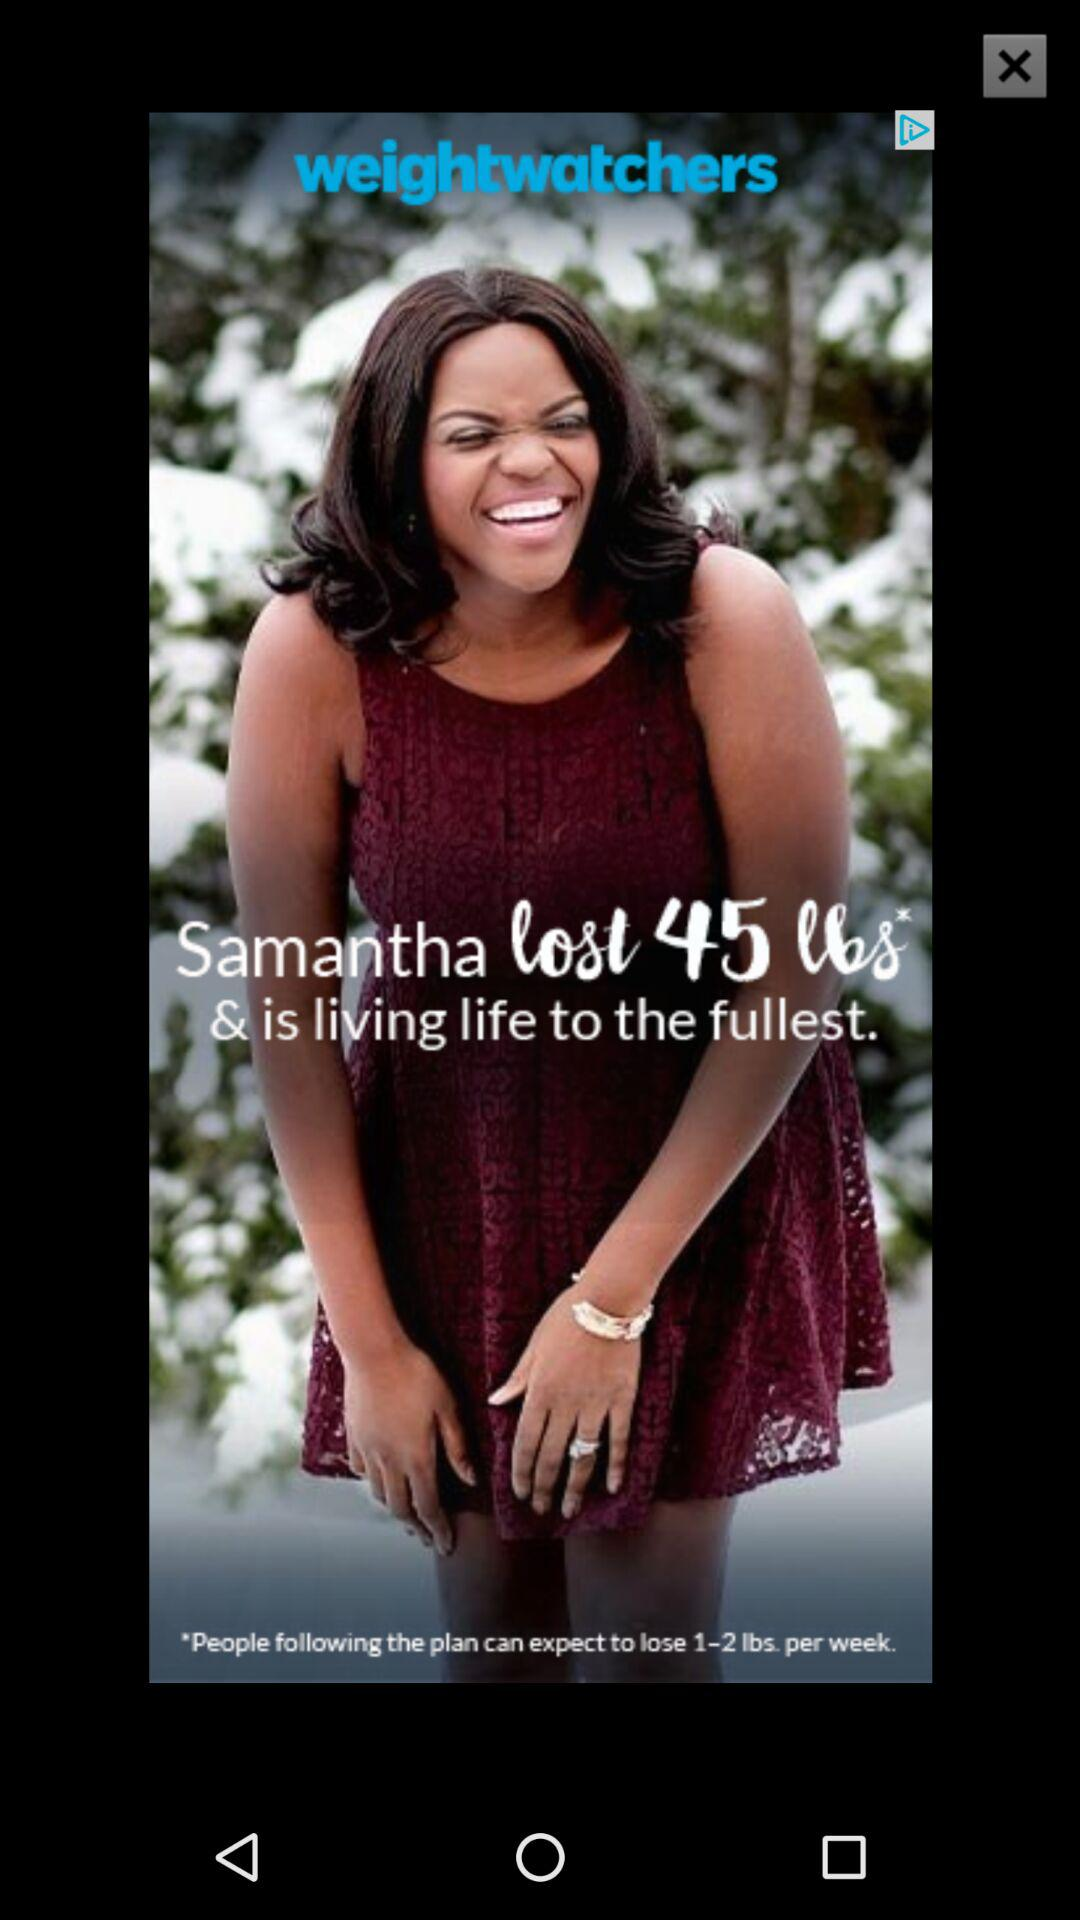What is the application name? The application name is "weightwatchers". 